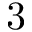<formula> <loc_0><loc_0><loc_500><loc_500>3</formula> 